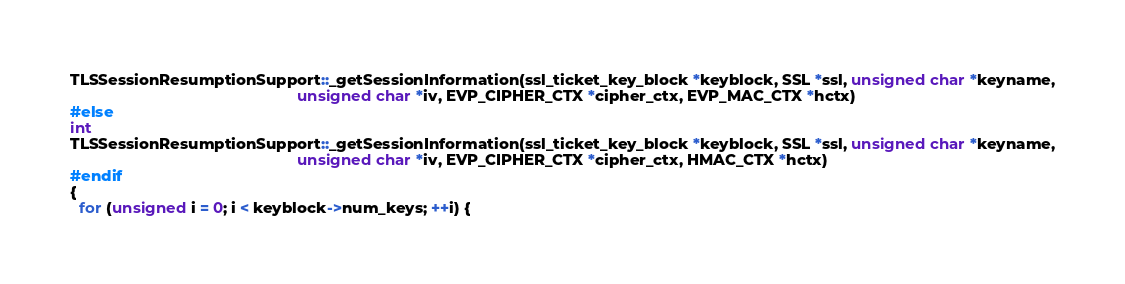Convert code to text. <code><loc_0><loc_0><loc_500><loc_500><_C++_>TLSSessionResumptionSupport::_getSessionInformation(ssl_ticket_key_block *keyblock, SSL *ssl, unsigned char *keyname,
                                                    unsigned char *iv, EVP_CIPHER_CTX *cipher_ctx, EVP_MAC_CTX *hctx)
#else
int
TLSSessionResumptionSupport::_getSessionInformation(ssl_ticket_key_block *keyblock, SSL *ssl, unsigned char *keyname,
                                                    unsigned char *iv, EVP_CIPHER_CTX *cipher_ctx, HMAC_CTX *hctx)
#endif
{
  for (unsigned i = 0; i < keyblock->num_keys; ++i) {</code> 